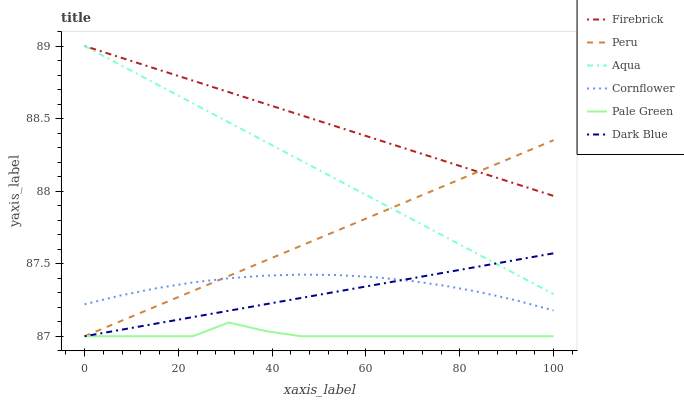Does Pale Green have the minimum area under the curve?
Answer yes or no. Yes. Does Firebrick have the maximum area under the curve?
Answer yes or no. Yes. Does Aqua have the minimum area under the curve?
Answer yes or no. No. Does Aqua have the maximum area under the curve?
Answer yes or no. No. Is Firebrick the smoothest?
Answer yes or no. Yes. Is Pale Green the roughest?
Answer yes or no. Yes. Is Aqua the smoothest?
Answer yes or no. No. Is Aqua the roughest?
Answer yes or no. No. Does Aqua have the lowest value?
Answer yes or no. No. Does Dark Blue have the highest value?
Answer yes or no. No. Is Cornflower less than Firebrick?
Answer yes or no. Yes. Is Aqua greater than Cornflower?
Answer yes or no. Yes. Does Cornflower intersect Firebrick?
Answer yes or no. No. 